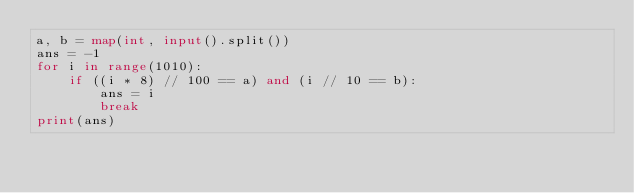<code> <loc_0><loc_0><loc_500><loc_500><_Python_>a, b = map(int, input().split())
ans = -1
for i in range(1010):
    if ((i * 8) // 100 == a) and (i // 10 == b):
        ans = i
        break
print(ans)</code> 